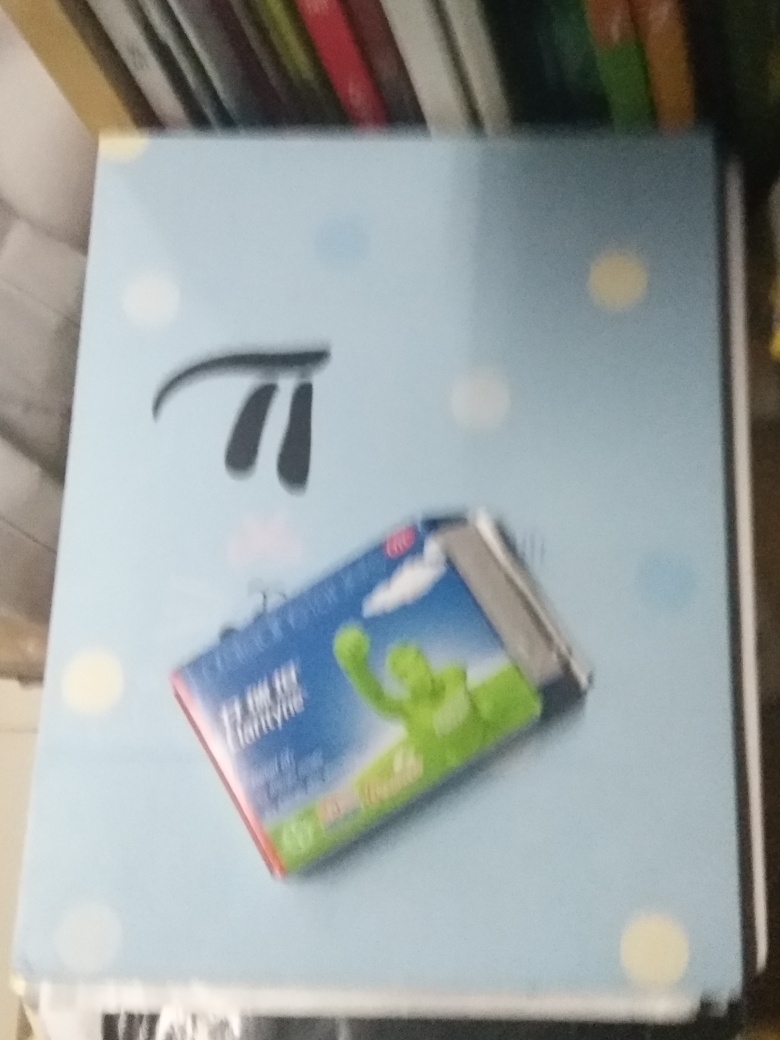Can you describe what is depicted in the image? This image features a box of toothpaste lying on a surface with a light blue, polka-dotted background. The toothpaste box appears to have the image of a muscular figure enjoying a fresh breath of air, potentially indicating that the product promises fresh breath. Due to the blurriness, it is challenging to read the text or make out finer details.  What can you deduce about the setting or the environment where this photo was taken? Given the limited context and the blurriness, it’s difficult to precisely deduce the setting of the image. However, the neat arrangement and the object, which suggests personal care, could imply that the photograph was taken inside a domestic space, such as a bathroom or bedroom shelf, where such items are commonly placed. 